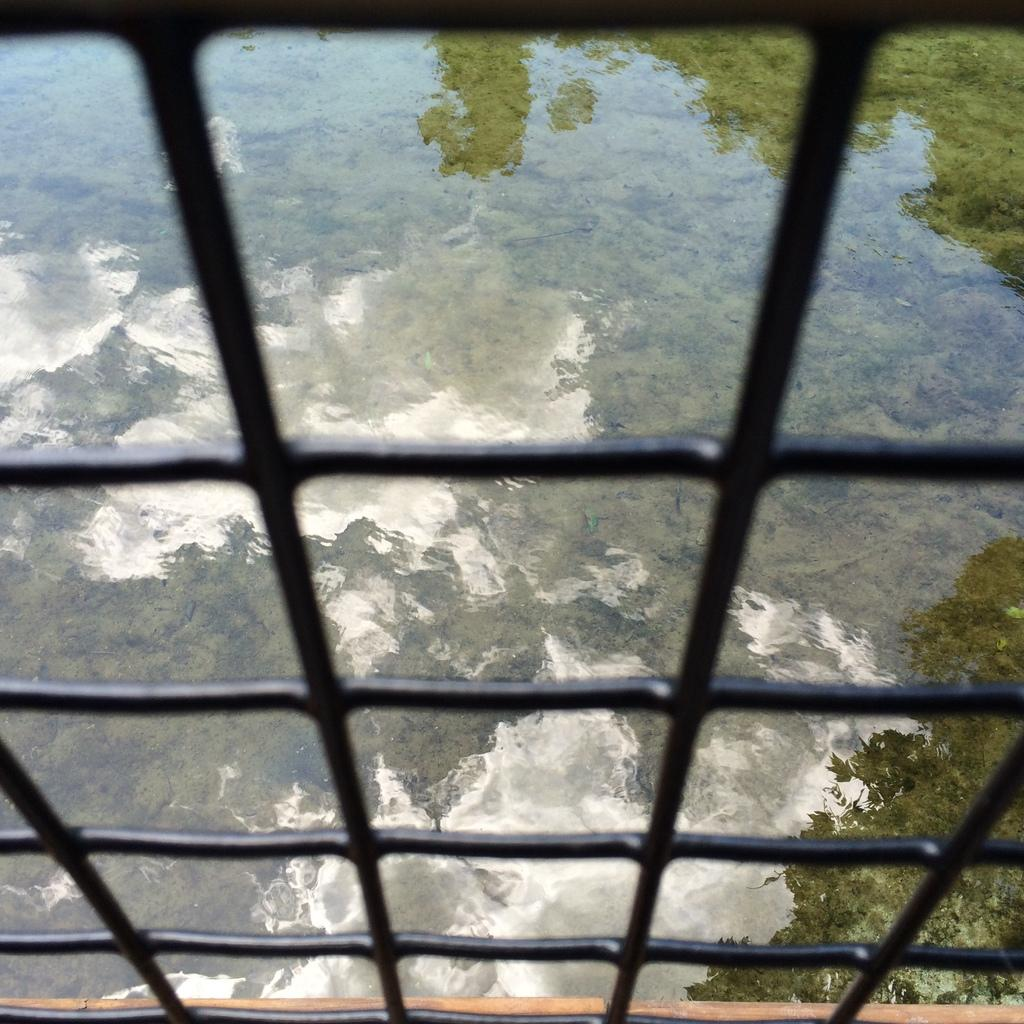Who is the main subject in the image? There is a girl in the image. What is the girl's position in relation to the water? The girl is positioned in front of water. What can be seen in the water's reflection? The reflection of trees is visible in the water. What type of popcorn is the girl holding in the image? There is no popcorn present in the image. How many babies are visible in the image? There are no babies visible in the image. 